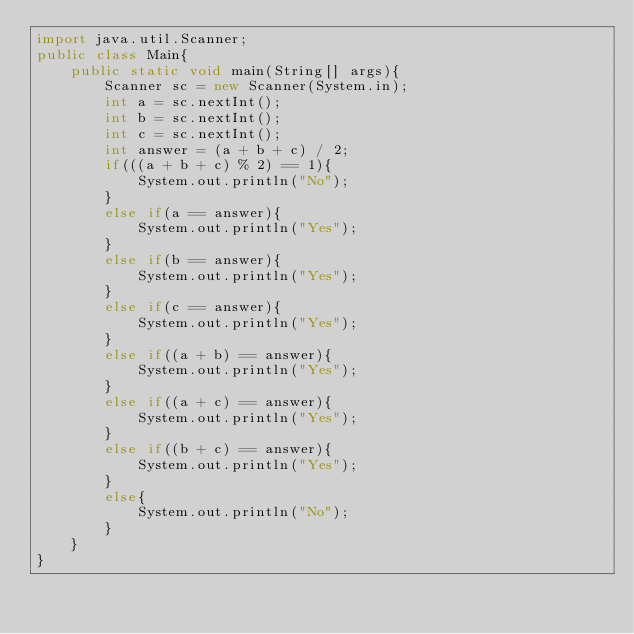Convert code to text. <code><loc_0><loc_0><loc_500><loc_500><_Java_>import java.util.Scanner;
public class Main{
    public static void main(String[] args){
        Scanner sc = new Scanner(System.in);
        int a = sc.nextInt();
        int b = sc.nextInt();
        int c = sc.nextInt();
        int answer = (a + b + c) / 2;
        if(((a + b + c) % 2) == 1){
            System.out.println("No");
        }
        else if(a == answer){
            System.out.println("Yes");
        }
        else if(b == answer){
            System.out.println("Yes");
        }
        else if(c == answer){
            System.out.println("Yes");
        }
        else if((a + b) == answer){
            System.out.println("Yes");
        }
        else if((a + c) == answer){
            System.out.println("Yes");
        }
        else if((b + c) == answer){
            System.out.println("Yes");
        }
        else{
            System.out.println("No");
        }
    }
}
</code> 